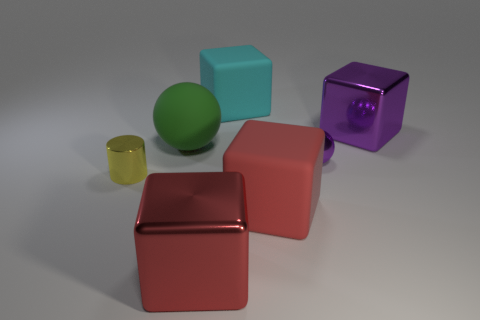Add 1 big metallic objects. How many objects exist? 8 Subtract all cylinders. How many objects are left? 6 Subtract 0 blue spheres. How many objects are left? 7 Subtract all large rubber spheres. Subtract all cyan matte cubes. How many objects are left? 5 Add 1 cyan rubber cubes. How many cyan rubber cubes are left? 2 Add 7 large purple spheres. How many large purple spheres exist? 7 